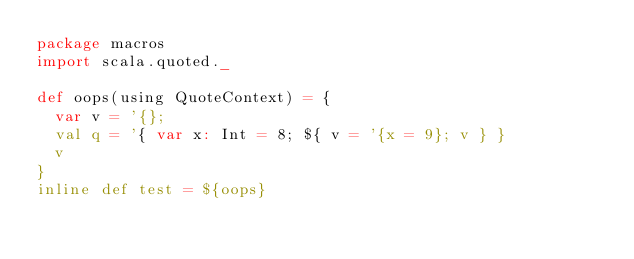Convert code to text. <code><loc_0><loc_0><loc_500><loc_500><_Scala_>package macros
import scala.quoted._

def oops(using QuoteContext) = {
  var v = '{};
  val q = '{ var x: Int = 8; ${ v = '{x = 9}; v } }
  v
}
inline def test = ${oops}
</code> 